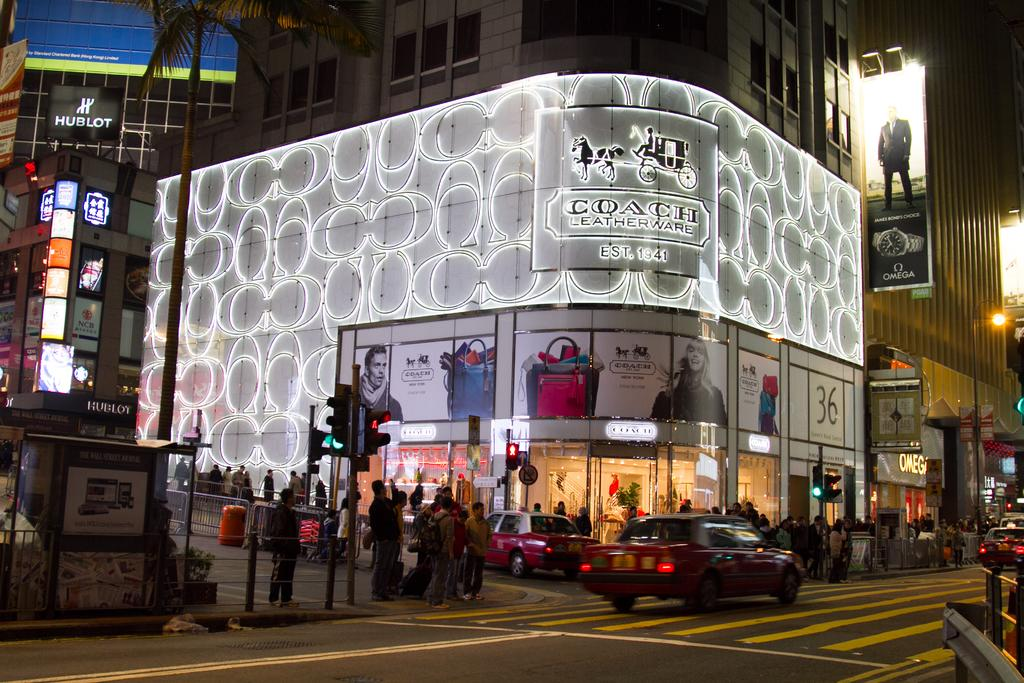<image>
Present a compact description of the photo's key features. The impressive corner shop is called Coach leatherware. 